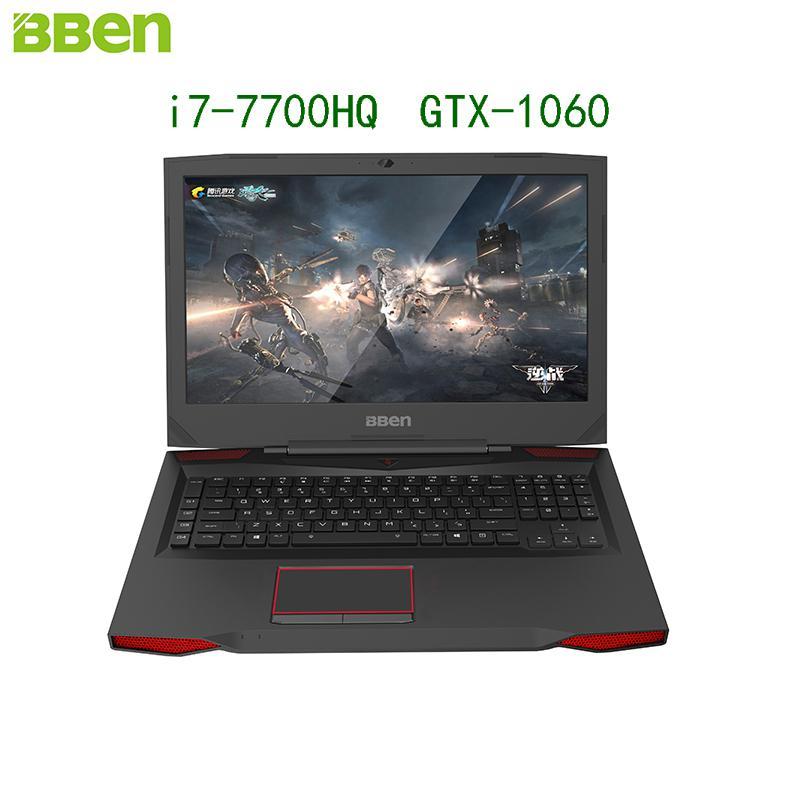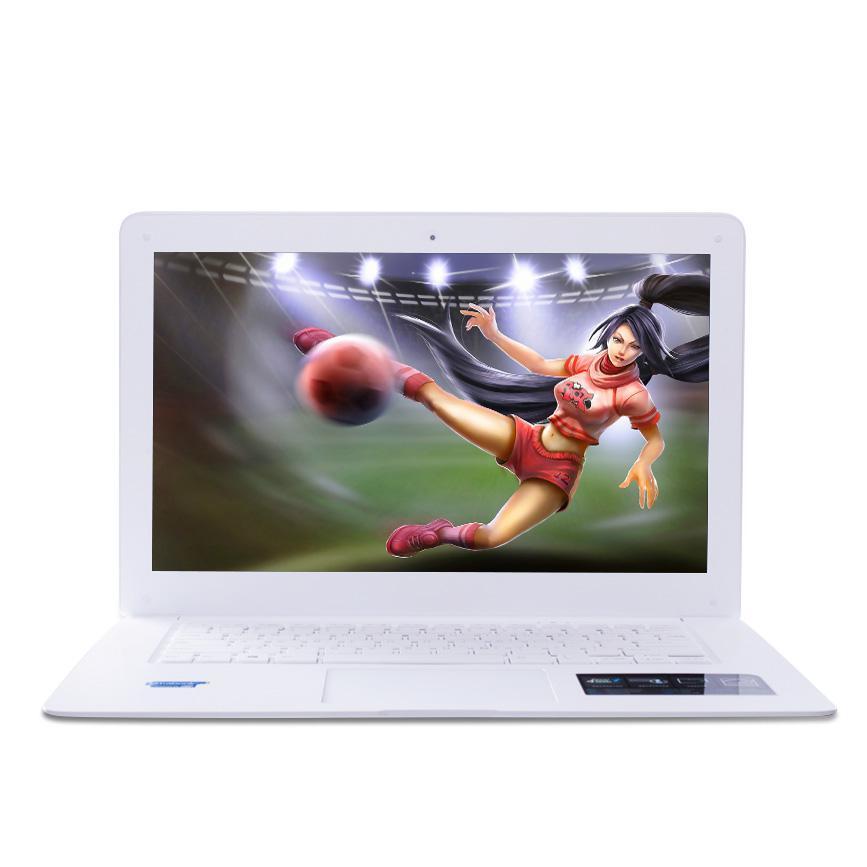The first image is the image on the left, the second image is the image on the right. Assess this claim about the two images: "There is a black laptop to the left of a lighter colored laptop". Correct or not? Answer yes or no. Yes. The first image is the image on the left, the second image is the image on the right. Examine the images to the left and right. Is the description "One fully open laptop computer is black, and a second laptop is a different color." accurate? Answer yes or no. Yes. 